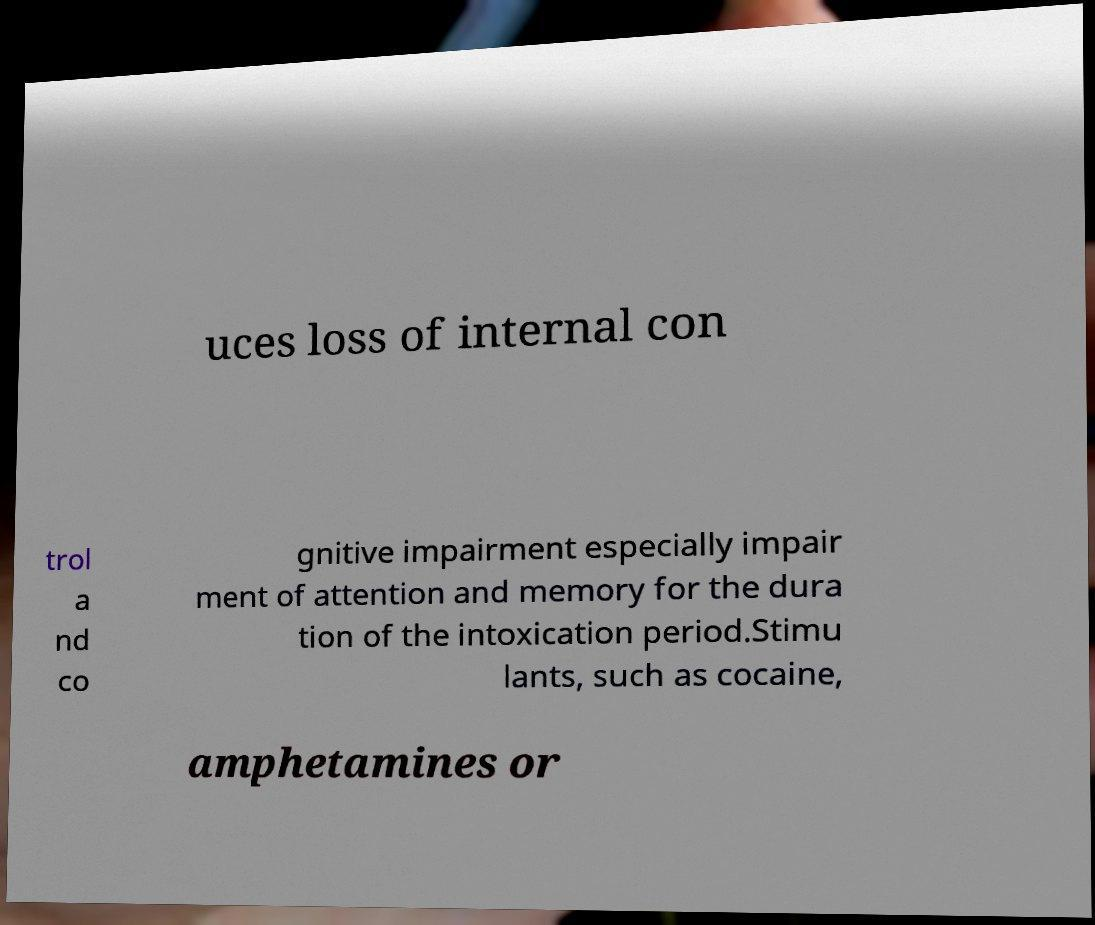Can you read and provide the text displayed in the image?This photo seems to have some interesting text. Can you extract and type it out for me? uces loss of internal con trol a nd co gnitive impairment especially impair ment of attention and memory for the dura tion of the intoxication period.Stimu lants, such as cocaine, amphetamines or 